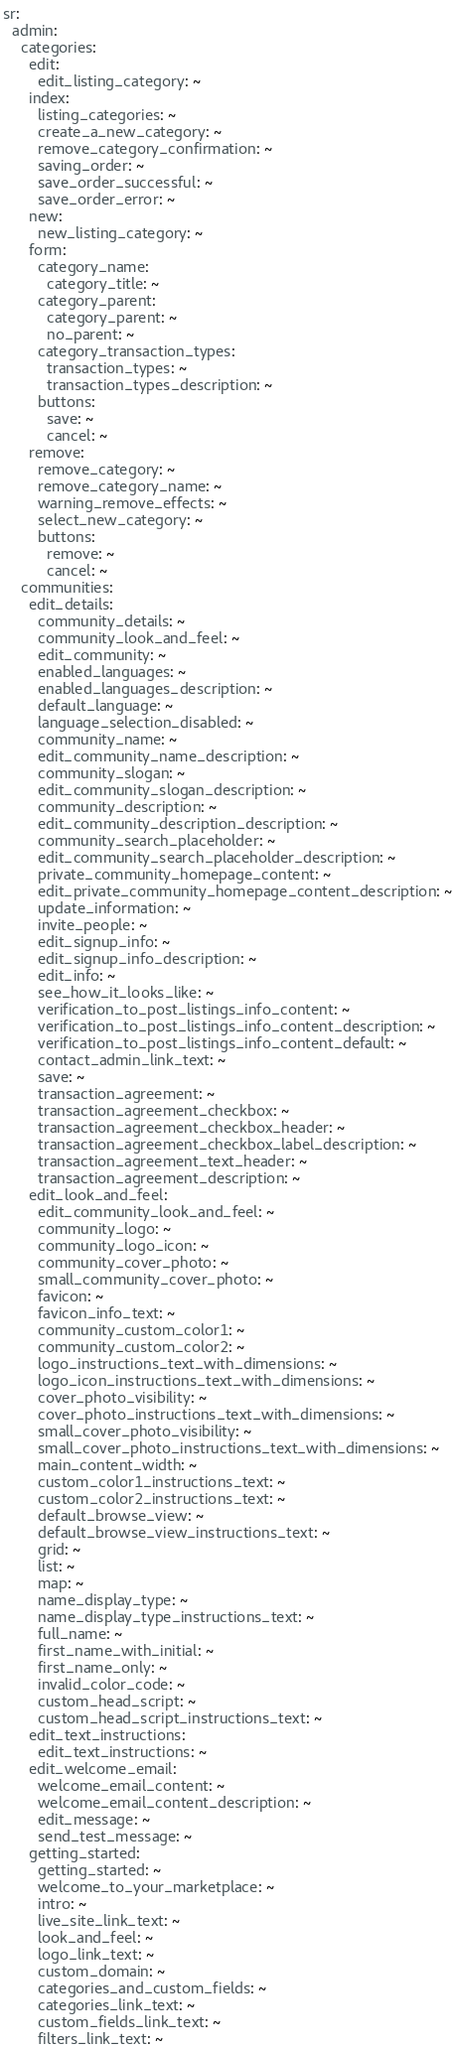Convert code to text. <code><loc_0><loc_0><loc_500><loc_500><_YAML_>sr:
  admin:
    categories:
      edit:
        edit_listing_category: ~
      index:
        listing_categories: ~
        create_a_new_category: ~
        remove_category_confirmation: ~
        saving_order: ~
        save_order_successful: ~
        save_order_error: ~
      new:
        new_listing_category: ~
      form:
        category_name:
          category_title: ~
        category_parent:
          category_parent: ~
          no_parent: ~
        category_transaction_types:
          transaction_types: ~
          transaction_types_description: ~
        buttons:
          save: ~
          cancel: ~
      remove:
        remove_category: ~
        remove_category_name: ~
        warning_remove_effects: ~
        select_new_category: ~
        buttons:
          remove: ~
          cancel: ~
    communities:
      edit_details:
        community_details: ~
        community_look_and_feel: ~
        edit_community: ~
        enabled_languages: ~
        enabled_languages_description: ~
        default_language: ~
        language_selection_disabled: ~
        community_name: ~
        edit_community_name_description: ~
        community_slogan: ~
        edit_community_slogan_description: ~
        community_description: ~
        edit_community_description_description: ~
        community_search_placeholder: ~
        edit_community_search_placeholder_description: ~
        private_community_homepage_content: ~
        edit_private_community_homepage_content_description: ~
        update_information: ~
        invite_people: ~
        edit_signup_info: ~
        edit_signup_info_description: ~
        edit_info: ~
        see_how_it_looks_like: ~
        verification_to_post_listings_info_content: ~
        verification_to_post_listings_info_content_description: ~
        verification_to_post_listings_info_content_default: ~
        contact_admin_link_text: ~
        save: ~
        transaction_agreement: ~
        transaction_agreement_checkbox: ~
        transaction_agreement_checkbox_header: ~
        transaction_agreement_checkbox_label_description: ~
        transaction_agreement_text_header: ~
        transaction_agreement_description: ~
      edit_look_and_feel:
        edit_community_look_and_feel: ~
        community_logo: ~
        community_logo_icon: ~
        community_cover_photo: ~
        small_community_cover_photo: ~
        favicon: ~
        favicon_info_text: ~
        community_custom_color1: ~
        community_custom_color2: ~
        logo_instructions_text_with_dimensions: ~
        logo_icon_instructions_text_with_dimensions: ~
        cover_photo_visibility: ~
        cover_photo_instructions_text_with_dimensions: ~
        small_cover_photo_visibility: ~
        small_cover_photo_instructions_text_with_dimensions: ~
        main_content_width: ~
        custom_color1_instructions_text: ~
        custom_color2_instructions_text: ~
        default_browse_view: ~
        default_browse_view_instructions_text: ~
        grid: ~
        list: ~
        map: ~
        name_display_type: ~
        name_display_type_instructions_text: ~
        full_name: ~
        first_name_with_initial: ~
        first_name_only: ~
        invalid_color_code: ~
        custom_head_script: ~
        custom_head_script_instructions_text: ~
      edit_text_instructions:
        edit_text_instructions: ~
      edit_welcome_email:
        welcome_email_content: ~
        welcome_email_content_description: ~
        edit_message: ~
        send_test_message: ~
      getting_started:
        getting_started: ~
        welcome_to_your_marketplace: ~
        intro: ~
        live_site_link_text: ~
        look_and_feel: ~
        logo_link_text: ~
        custom_domain: ~
        categories_and_custom_fields: ~
        categories_link_text: ~
        custom_fields_link_text: ~
        filters_link_text: ~</code> 